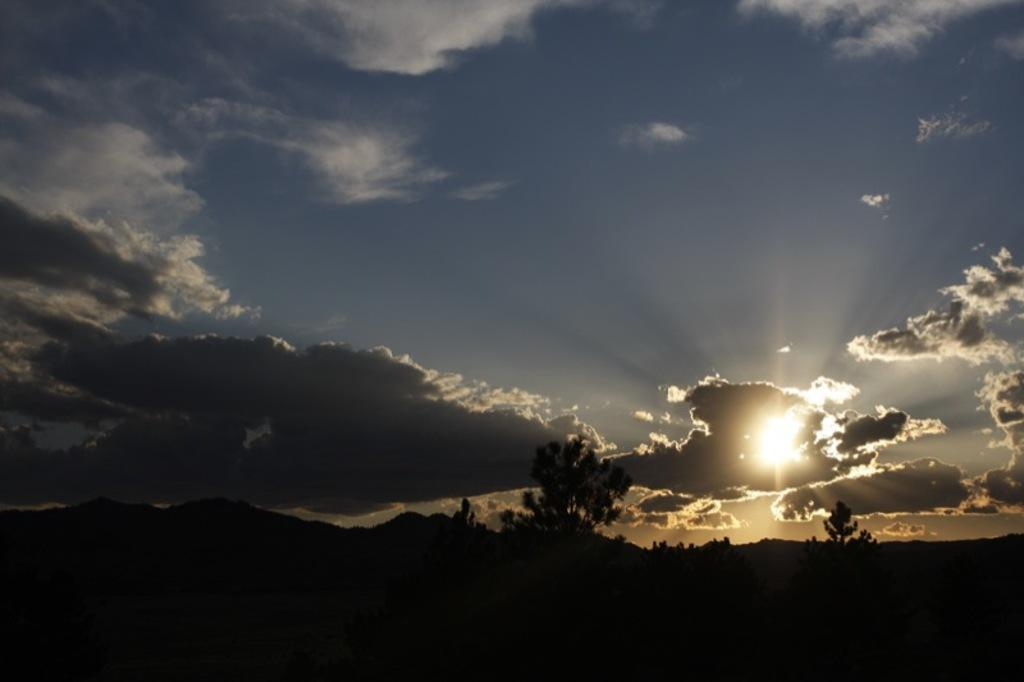What can be seen in the background of the image? The sky is visible in the image. What is the condition of the sky in the image? Clouds are present in the sky. What type of natural features can be seen in the image? There are hills and trees present in the image. What type of eggs does the father bring home in the image? There is no father or eggs present in the image. What thought is the person in the image having about the trees? There is no person or thought process visible in the image; it only shows the sky, clouds, hills, and trees. 